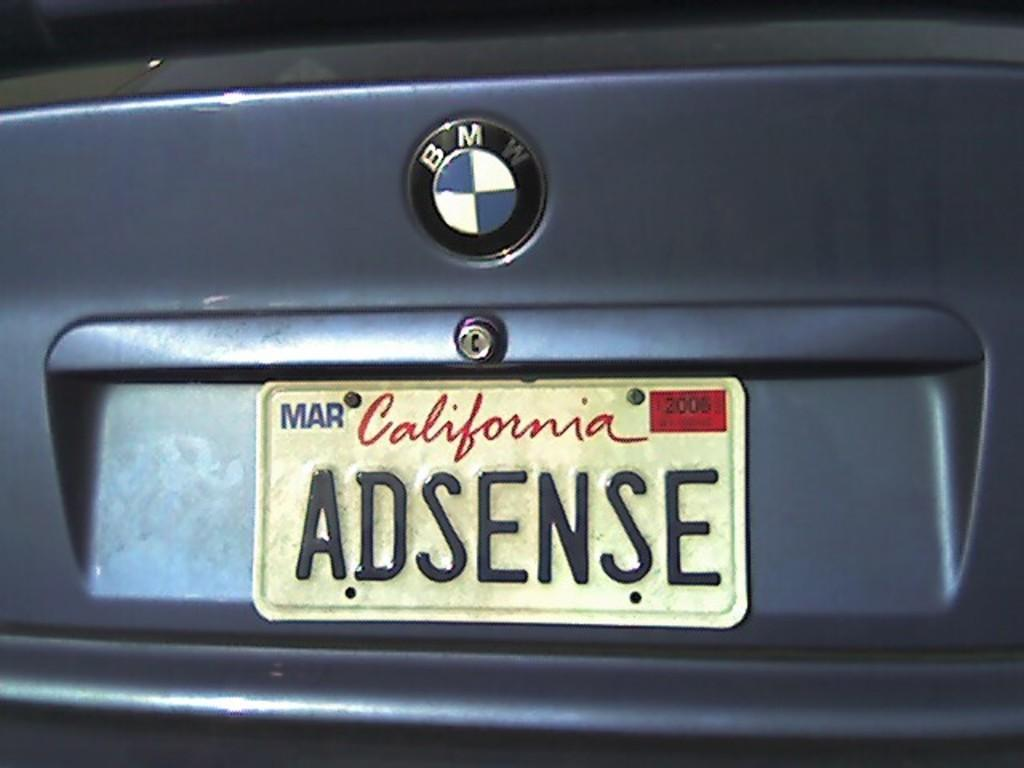<image>
Relay a brief, clear account of the picture shown. A BMW with a California license plate and the word Mar. 